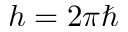<formula> <loc_0><loc_0><loc_500><loc_500>h = 2 \pi \hbar</formula> 